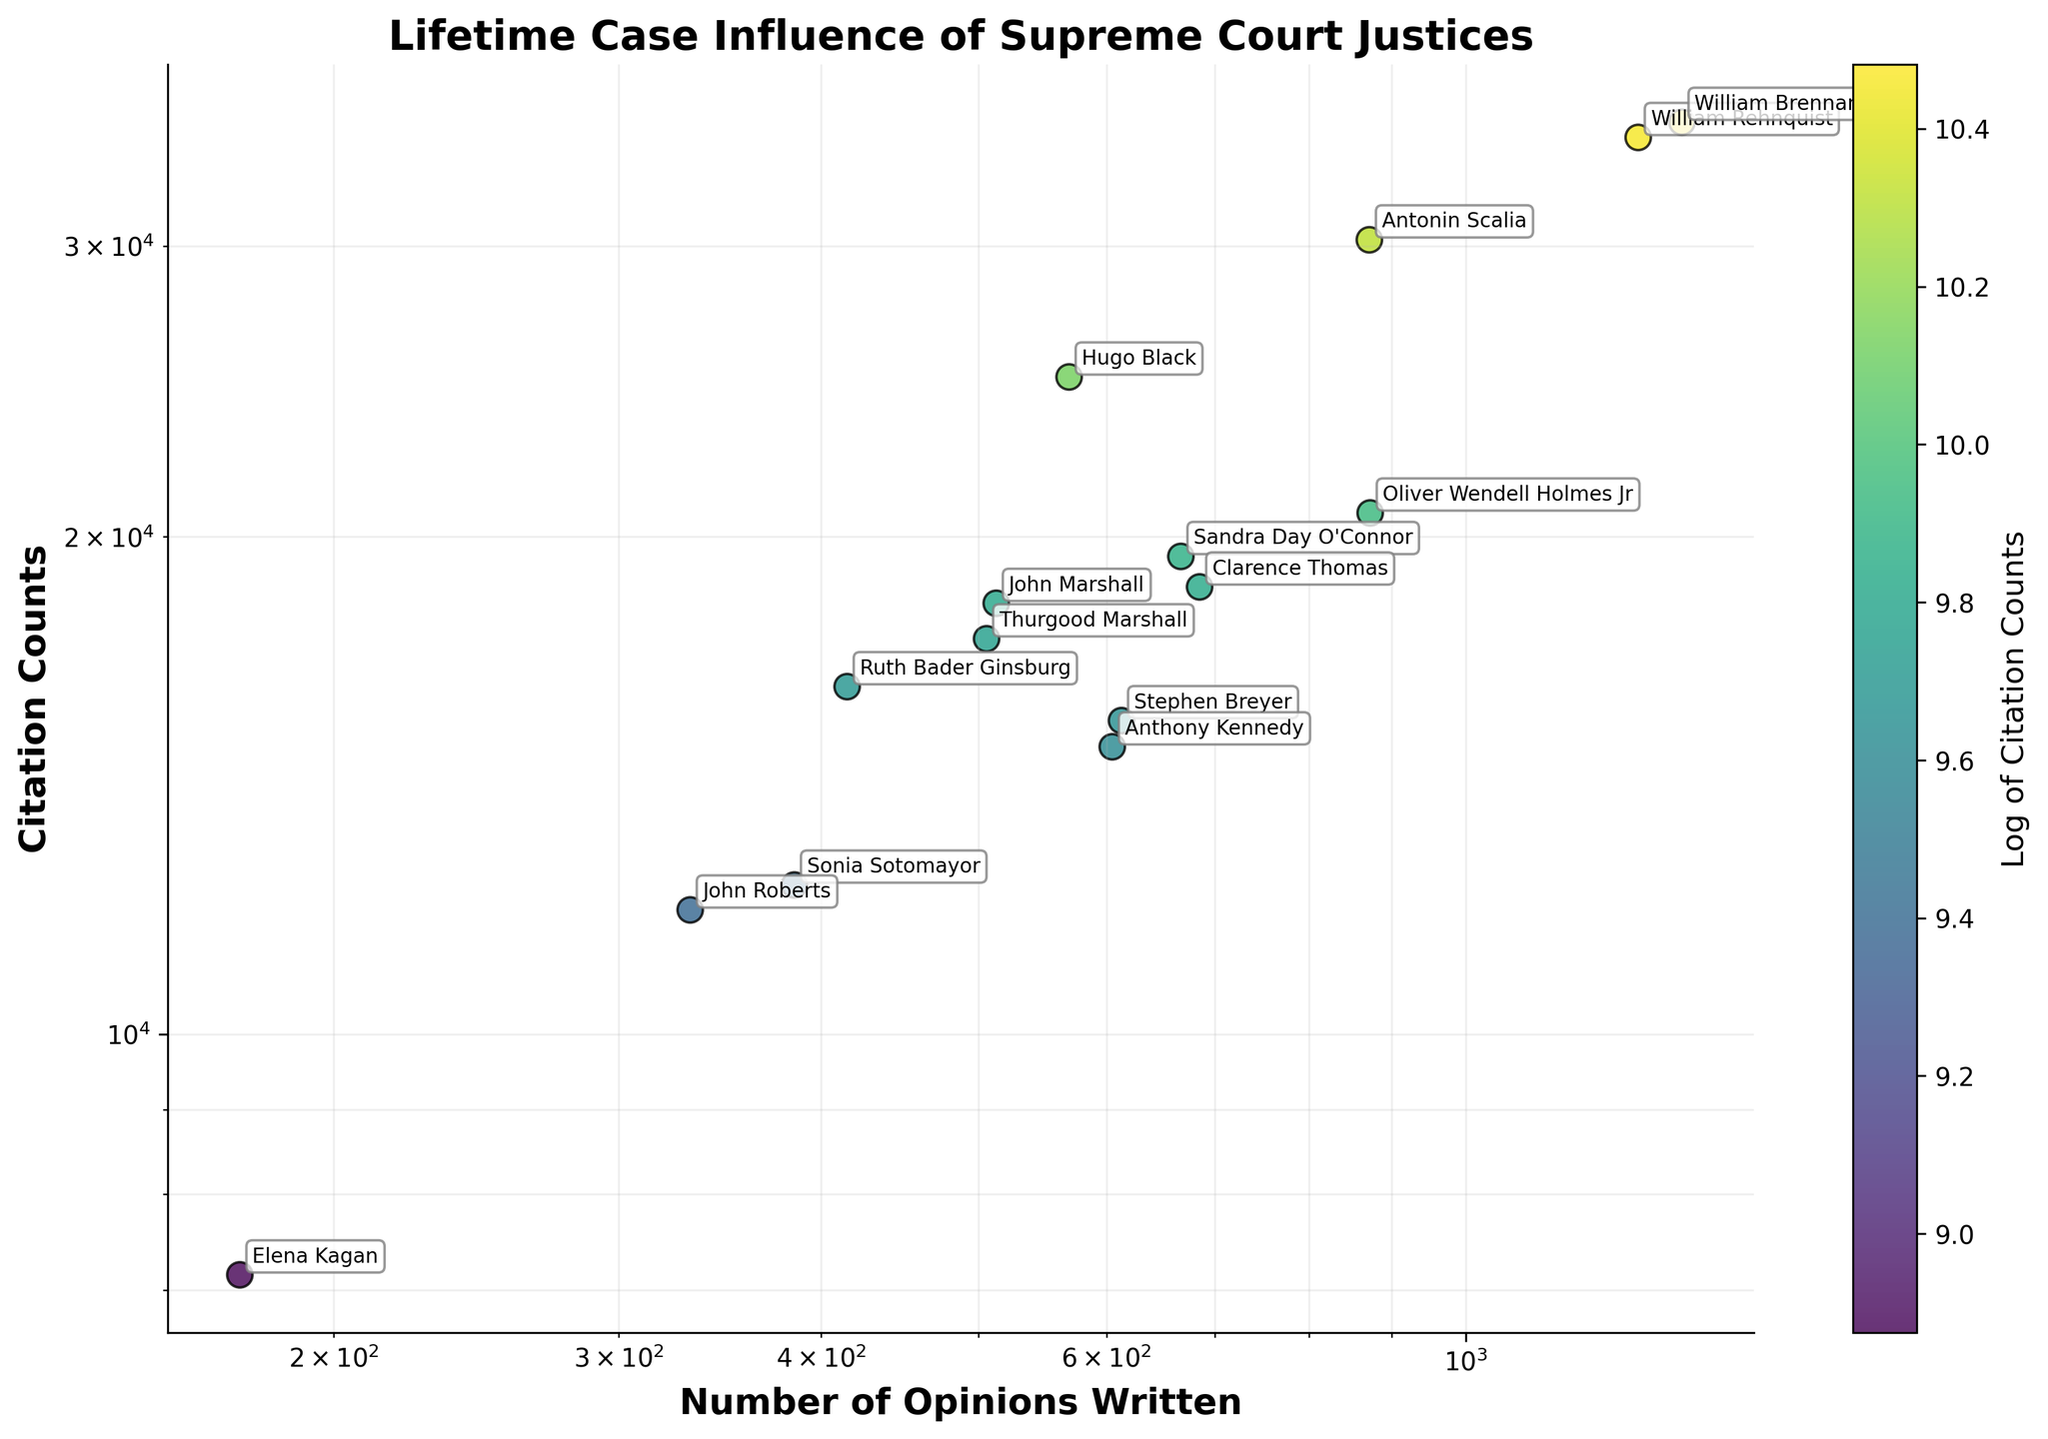What's the title of the figure? The title is displayed at the top of the figure.
Answer: Lifetime Case Influence of Supreme Court Justices How many justices are represented in the plot? Each data point represents a justice and there are 15 annotations in the figure.
Answer: 15 Which justice has the highest number of opinions written? Look for the justice with the highest x-value. William Brennan is annotated at the highest x-value.
Answer: William Brennan Who is the justice with the lowest citation counts? Identify the justice at the lowest y-value and check the annotation. Elena Kagan is annotated at the lowest y-value.
Answer: Elena Kagan Which justice has a higher citation count, Clarence Thomas or Sandra Day O'Connor? Compare the y-values of both justices. Sandra Day O'Connor has the higher y-value.
Answer: Sandra Day O'Connor What's the range of the Number of Opinions Written on the x-axis? Identify the range by looking at the minimum and maximum values on the logarithmic x-axis.
Answer: Approximately 100 to 2000 How does the number of opinions written by Thurgood Marshall compare to John Marshall? Thurgood Marshall is around 506, and John Marshall is at 513.
Answer: Almost equal Which justice among Ruth Bader Ginsburg, Stephen Breyer, and John Roberts has the lowest citation count? Compare the y-values of Ruth Bader Ginsburg, Stephen Breyer, and John Roberts. John Roberts has the lowest y-value.
Answer: John Roberts Is the citation count of William Rehnquist closer to Hugo Black or Antonin Scalia? Compare the vertical distance (y-values) between William Rehnquist and Hugo Black, and between William Rehnquist and Antonin Scalia. It's closer to Antonin Scalia.
Answer: Antonin Scalia Describe the correlation between the number of opinions written and citation counts. Observe the overall trend of the points. The scatter plot shows a positive correlation where justices with more opinions tend to have higher citation counts.
Answer: Positive correlation 